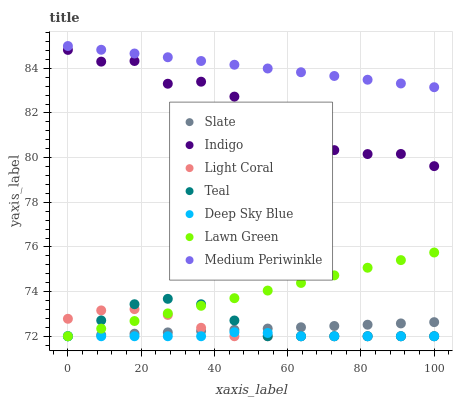Does Deep Sky Blue have the minimum area under the curve?
Answer yes or no. Yes. Does Medium Periwinkle have the maximum area under the curve?
Answer yes or no. Yes. Does Indigo have the minimum area under the curve?
Answer yes or no. No. Does Indigo have the maximum area under the curve?
Answer yes or no. No. Is Lawn Green the smoothest?
Answer yes or no. Yes. Is Indigo the roughest?
Answer yes or no. Yes. Is Teal the smoothest?
Answer yes or no. No. Is Teal the roughest?
Answer yes or no. No. Does Lawn Green have the lowest value?
Answer yes or no. Yes. Does Indigo have the lowest value?
Answer yes or no. No. Does Medium Periwinkle have the highest value?
Answer yes or no. Yes. Does Indigo have the highest value?
Answer yes or no. No. Is Teal less than Indigo?
Answer yes or no. Yes. Is Medium Periwinkle greater than Slate?
Answer yes or no. Yes. Does Light Coral intersect Teal?
Answer yes or no. Yes. Is Light Coral less than Teal?
Answer yes or no. No. Is Light Coral greater than Teal?
Answer yes or no. No. Does Teal intersect Indigo?
Answer yes or no. No. 